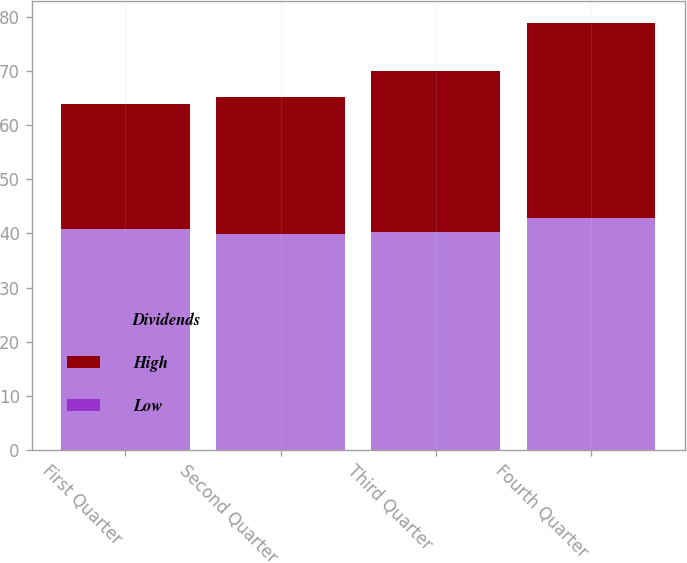Convert chart. <chart><loc_0><loc_0><loc_500><loc_500><stacked_bar_chart><ecel><fcel>First Quarter<fcel>Second Quarter<fcel>Third Quarter<fcel>Fourth Quarter<nl><fcel>Dividends<fcel>40.74<fcel>39.94<fcel>40.18<fcel>42.91<nl><fcel>High<fcel>23.14<fcel>25.19<fcel>29.84<fcel>36<nl><fcel>Low<fcel>0.01<fcel>0.01<fcel>0.01<fcel>0.01<nl></chart> 